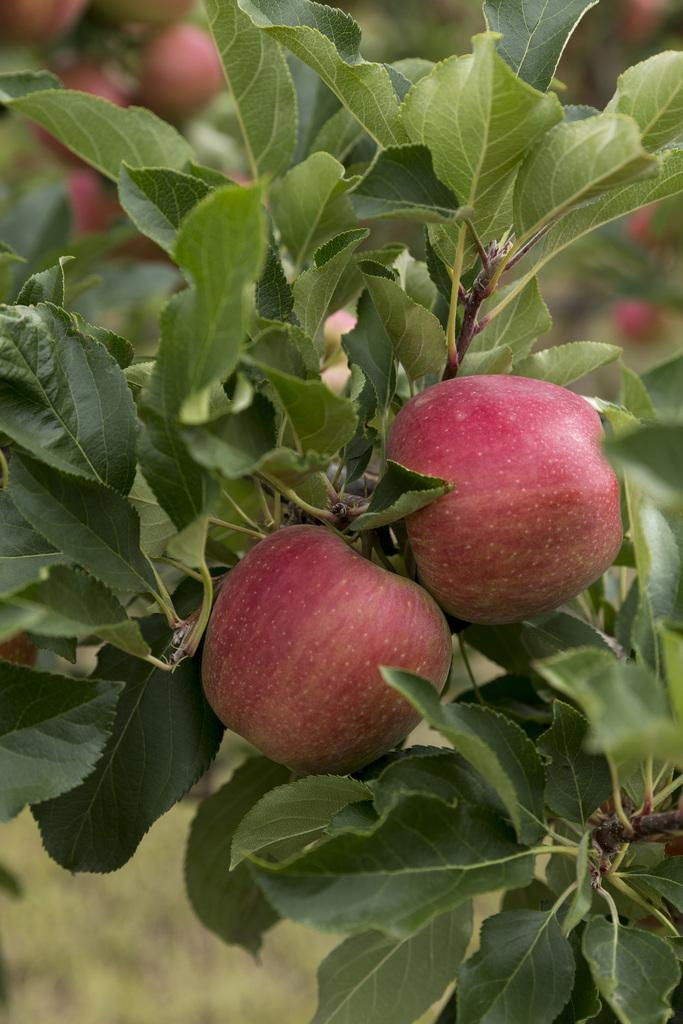What type of fruit is present in the image? There are apples in the image. What color are the leaves associated with the apples? The leaves in the image are green. Can you describe the background of the image? The background of the image is blurred. How many books are stacked on the toes of the person in the image? There are no books or people present in the image; it features apples and green leaves. 